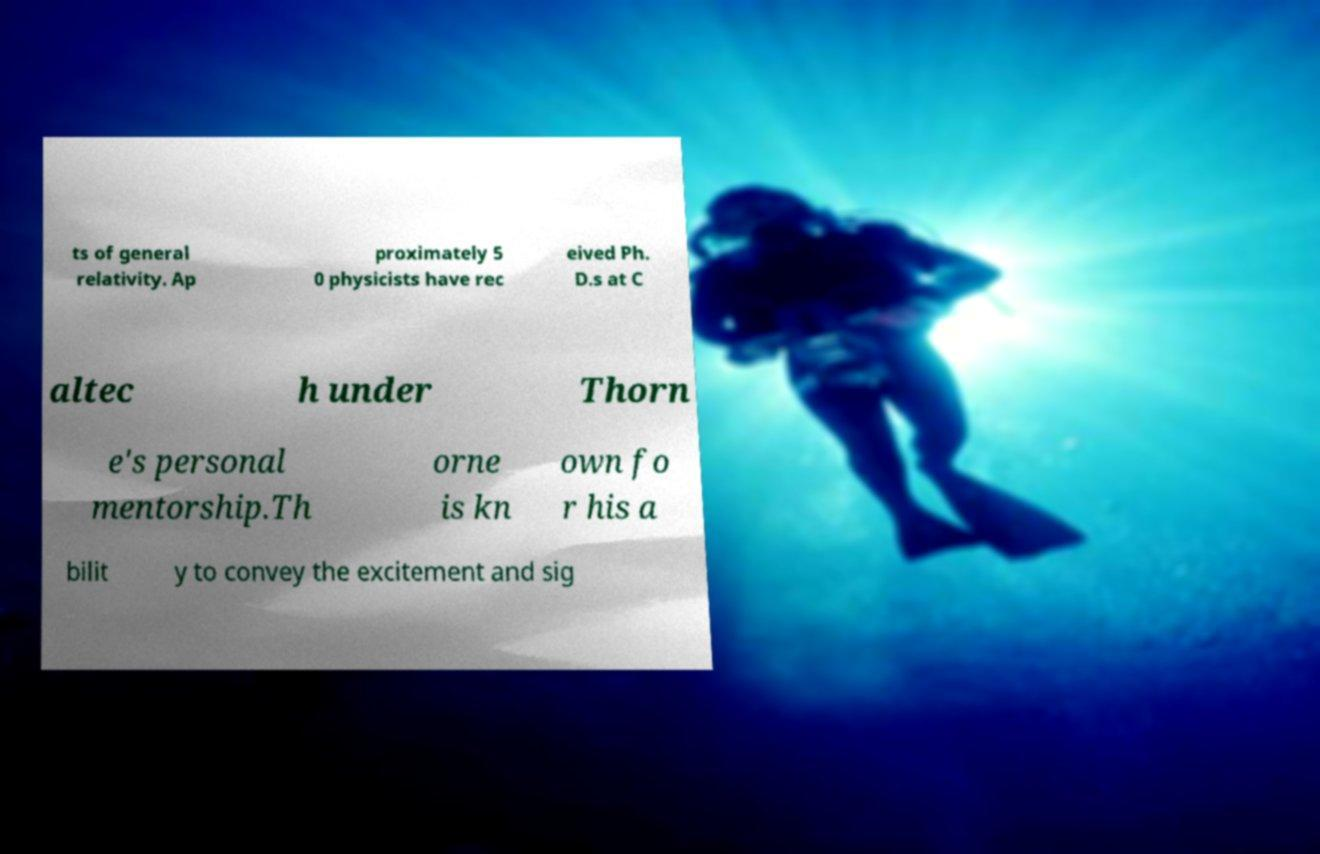Could you assist in decoding the text presented in this image and type it out clearly? ts of general relativity. Ap proximately 5 0 physicists have rec eived Ph. D.s at C altec h under Thorn e's personal mentorship.Th orne is kn own fo r his a bilit y to convey the excitement and sig 